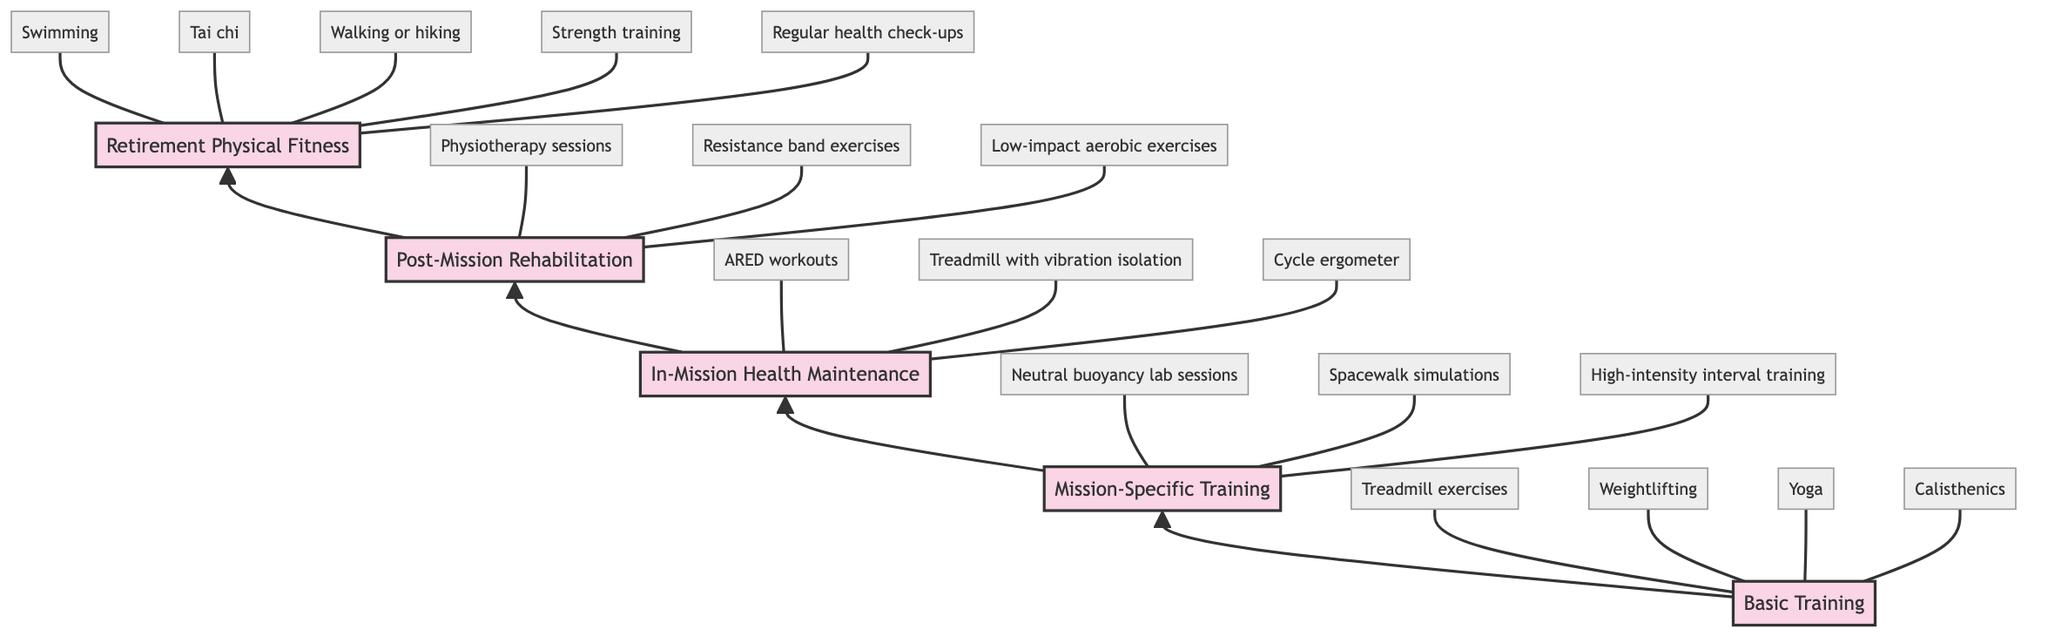What is the last stage in the fitness journey? The last stage in the diagram flows from 'Post-Mission Rehabilitation', leading to 'Retirement Physical Fitness' at the top. This is the final node in the sequence presented.
Answer: Retirement Physical Fitness How many activities are associated with Basic Training? In the Basic Training stage, there are four specific activities listed: treadmill exercises, weightlifting, yoga, and calisthenics. Therefore, counting these gives the total number of associated activities.
Answer: 4 Which stage involves using ARED workouts? The stage detailing the use of ARED workouts is 'In-Mission Health Maintenance'. This stage specifically lists ARED workouts as one of the activities to maintain health during missions.
Answer: In-Mission Health Maintenance What type of training occurs right before Post-Mission Rehabilitation? Right before the 'Post-Mission Rehabilitation' stage is 'In-Mission Health Maintenance'. The diagram shows a direct upward connection from In-Mission Health Maintenance to Post-Mission Rehabilitation.
Answer: In-Mission Health Maintenance List one activity from Mission-Specific Training. There are three activities listed under 'Mission-Specific Training', any one of which can be given as the answer. For example, 'neutral buoyancy lab sessions', 'spacewalk simulations', or 'high-intensity interval training' qualifies.
Answer: Neutral buoyancy lab sessions What is a common activity during Retirement Physical Fitness? The stage 'Retirement Physical Fitness' includes several activities, one of which is 'swimming'. This suffices as a common activity from this stage.
Answer: Swimming How many stages are there in total? The total number of stages depicted in the diagram includes five distinct stages: Basic Training, Mission-Specific Training, In-Mission Health Maintenance, Post-Mission Rehabilitation, and Retirement Physical Fitness. Therefore, counting these gives the total number of stages present.
Answer: 5 Which training is focused on underwater training? The training that is concentrated on underwater training to simulate zero-gravity conditions is 'Mission-Specific Training'. This stage specifies the preparation for the unique demands of space missions.
Answer: Mission-Specific Training 